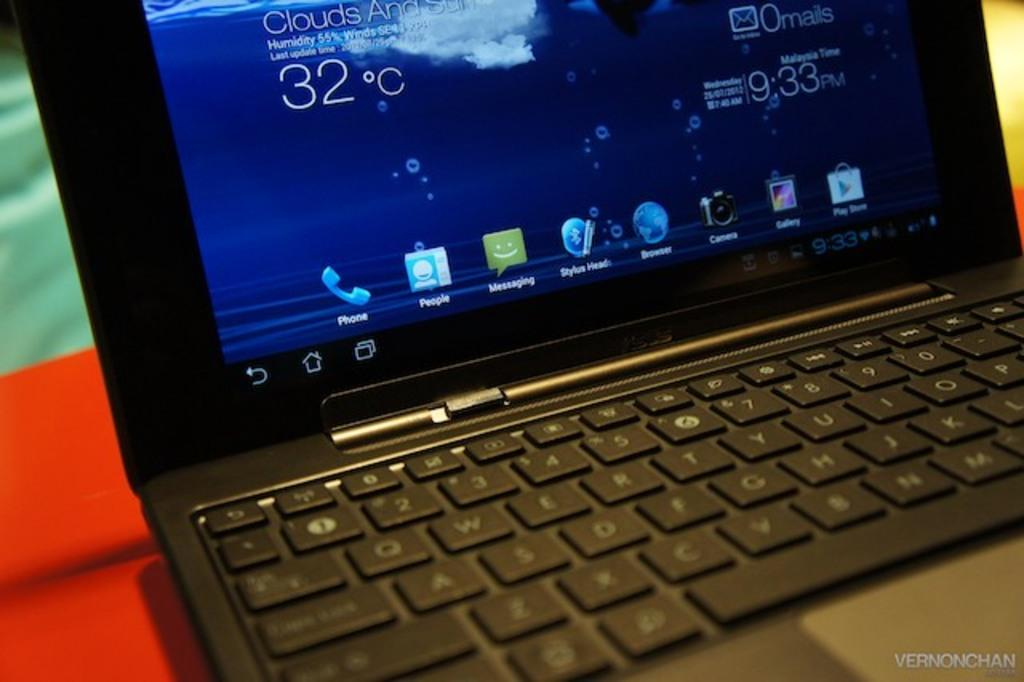Provide a one-sentence caption for the provided image. A laptop screen showing the weather as 32 degrees Celsius. 